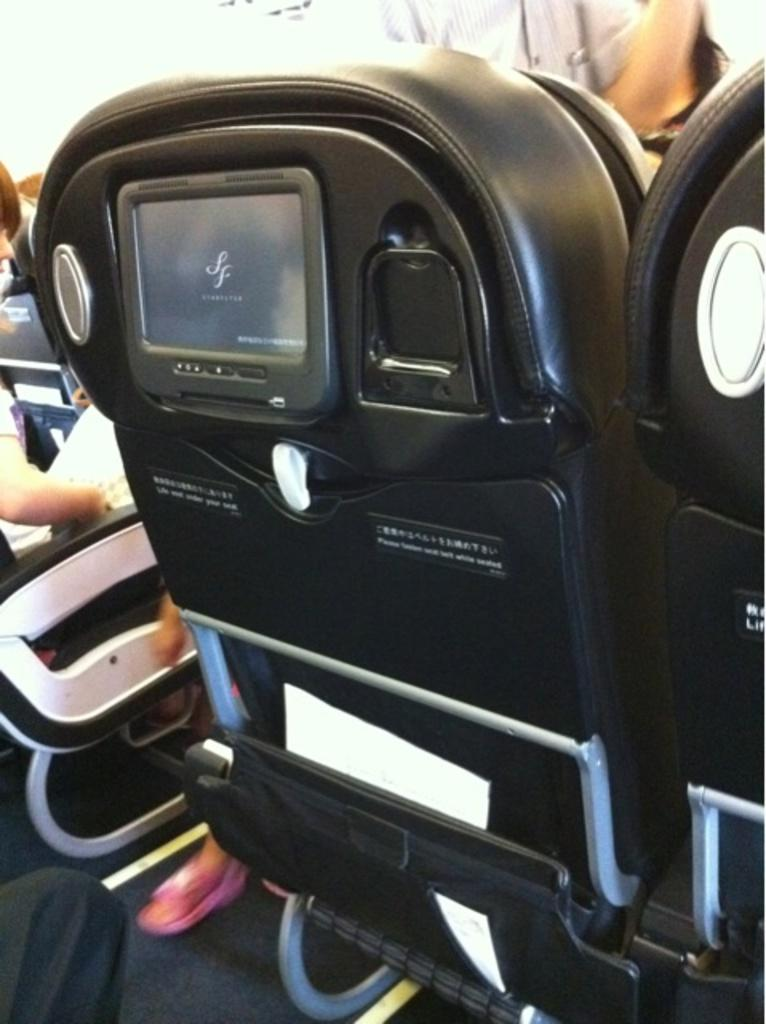What type of furniture can be seen in the image? There are chairs in the image. Can you describe the position of the person in the image? There is a person sitting on a chair on the left side. What is unique about one of the chairs in the image? There is a screen attached to a chair. What is the color of the chair with the screen? The chair with the screen is in black color. What type of protest is the person leading in the image? There is no protest present in the image; it only shows chairs and a person sitting on one of them. 